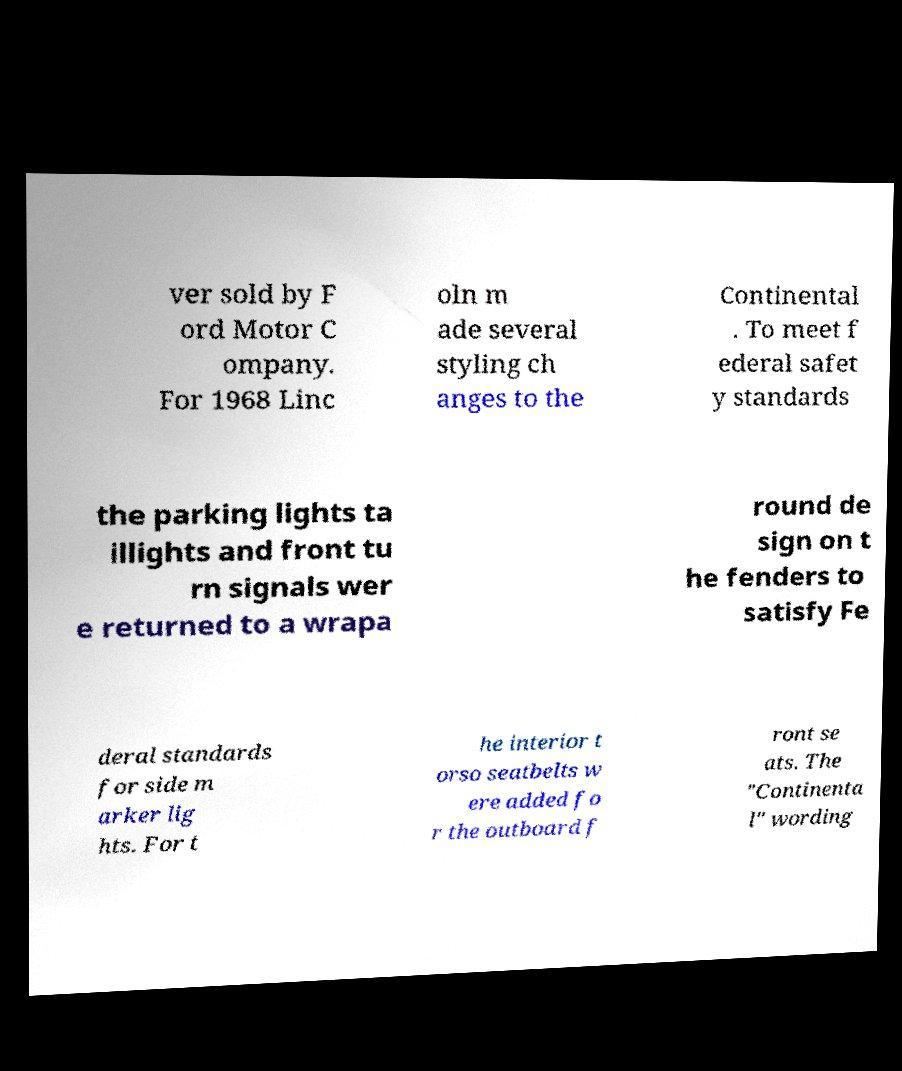I need the written content from this picture converted into text. Can you do that? ver sold by F ord Motor C ompany. For 1968 Linc oln m ade several styling ch anges to the Continental . To meet f ederal safet y standards the parking lights ta illights and front tu rn signals wer e returned to a wrapa round de sign on t he fenders to satisfy Fe deral standards for side m arker lig hts. For t he interior t orso seatbelts w ere added fo r the outboard f ront se ats. The "Continenta l" wording 